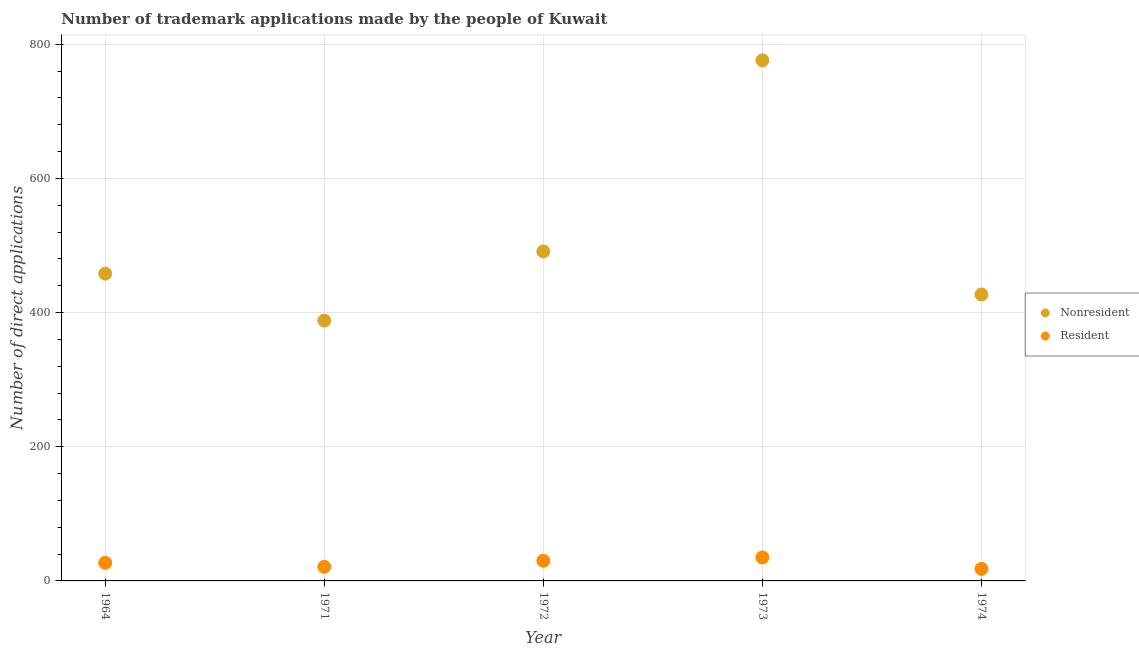How many different coloured dotlines are there?
Give a very brief answer. 2. What is the number of trademark applications made by non residents in 1971?
Give a very brief answer. 388. Across all years, what is the maximum number of trademark applications made by non residents?
Keep it short and to the point. 776. Across all years, what is the minimum number of trademark applications made by non residents?
Give a very brief answer. 388. What is the total number of trademark applications made by residents in the graph?
Provide a succinct answer. 131. What is the difference between the number of trademark applications made by residents in 1971 and that in 1973?
Provide a short and direct response. -14. What is the difference between the number of trademark applications made by non residents in 1964 and the number of trademark applications made by residents in 1971?
Your answer should be very brief. 437. What is the average number of trademark applications made by non residents per year?
Give a very brief answer. 508. In the year 1973, what is the difference between the number of trademark applications made by residents and number of trademark applications made by non residents?
Give a very brief answer. -741. In how many years, is the number of trademark applications made by non residents greater than 560?
Offer a very short reply. 1. Is the difference between the number of trademark applications made by non residents in 1971 and 1973 greater than the difference between the number of trademark applications made by residents in 1971 and 1973?
Your answer should be compact. No. What is the difference between the highest and the second highest number of trademark applications made by residents?
Your response must be concise. 5. What is the difference between the highest and the lowest number of trademark applications made by non residents?
Keep it short and to the point. 388. Does the number of trademark applications made by residents monotonically increase over the years?
Ensure brevity in your answer.  No. Are the values on the major ticks of Y-axis written in scientific E-notation?
Keep it short and to the point. No. Does the graph contain any zero values?
Offer a very short reply. No. Does the graph contain grids?
Offer a terse response. Yes. Where does the legend appear in the graph?
Make the answer very short. Center right. How are the legend labels stacked?
Your answer should be very brief. Vertical. What is the title of the graph?
Provide a short and direct response. Number of trademark applications made by the people of Kuwait. Does "Male" appear as one of the legend labels in the graph?
Your answer should be compact. No. What is the label or title of the Y-axis?
Provide a short and direct response. Number of direct applications. What is the Number of direct applications of Nonresident in 1964?
Provide a short and direct response. 458. What is the Number of direct applications of Resident in 1964?
Offer a terse response. 27. What is the Number of direct applications in Nonresident in 1971?
Ensure brevity in your answer.  388. What is the Number of direct applications of Nonresident in 1972?
Ensure brevity in your answer.  491. What is the Number of direct applications of Nonresident in 1973?
Offer a terse response. 776. What is the Number of direct applications of Nonresident in 1974?
Keep it short and to the point. 427. Across all years, what is the maximum Number of direct applications of Nonresident?
Keep it short and to the point. 776. Across all years, what is the minimum Number of direct applications in Nonresident?
Give a very brief answer. 388. Across all years, what is the minimum Number of direct applications in Resident?
Make the answer very short. 18. What is the total Number of direct applications in Nonresident in the graph?
Give a very brief answer. 2540. What is the total Number of direct applications of Resident in the graph?
Make the answer very short. 131. What is the difference between the Number of direct applications of Resident in 1964 and that in 1971?
Make the answer very short. 6. What is the difference between the Number of direct applications in Nonresident in 1964 and that in 1972?
Your response must be concise. -33. What is the difference between the Number of direct applications in Nonresident in 1964 and that in 1973?
Offer a very short reply. -318. What is the difference between the Number of direct applications in Nonresident in 1971 and that in 1972?
Provide a short and direct response. -103. What is the difference between the Number of direct applications in Resident in 1971 and that in 1972?
Offer a terse response. -9. What is the difference between the Number of direct applications in Nonresident in 1971 and that in 1973?
Your answer should be very brief. -388. What is the difference between the Number of direct applications in Nonresident in 1971 and that in 1974?
Make the answer very short. -39. What is the difference between the Number of direct applications in Nonresident in 1972 and that in 1973?
Offer a very short reply. -285. What is the difference between the Number of direct applications of Nonresident in 1972 and that in 1974?
Provide a succinct answer. 64. What is the difference between the Number of direct applications in Nonresident in 1973 and that in 1974?
Provide a succinct answer. 349. What is the difference between the Number of direct applications in Nonresident in 1964 and the Number of direct applications in Resident in 1971?
Offer a very short reply. 437. What is the difference between the Number of direct applications of Nonresident in 1964 and the Number of direct applications of Resident in 1972?
Your answer should be compact. 428. What is the difference between the Number of direct applications in Nonresident in 1964 and the Number of direct applications in Resident in 1973?
Your answer should be compact. 423. What is the difference between the Number of direct applications of Nonresident in 1964 and the Number of direct applications of Resident in 1974?
Your answer should be compact. 440. What is the difference between the Number of direct applications in Nonresident in 1971 and the Number of direct applications in Resident in 1972?
Your response must be concise. 358. What is the difference between the Number of direct applications of Nonresident in 1971 and the Number of direct applications of Resident in 1973?
Make the answer very short. 353. What is the difference between the Number of direct applications of Nonresident in 1971 and the Number of direct applications of Resident in 1974?
Ensure brevity in your answer.  370. What is the difference between the Number of direct applications of Nonresident in 1972 and the Number of direct applications of Resident in 1973?
Provide a succinct answer. 456. What is the difference between the Number of direct applications in Nonresident in 1972 and the Number of direct applications in Resident in 1974?
Your answer should be compact. 473. What is the difference between the Number of direct applications of Nonresident in 1973 and the Number of direct applications of Resident in 1974?
Your answer should be very brief. 758. What is the average Number of direct applications in Nonresident per year?
Your answer should be compact. 508. What is the average Number of direct applications in Resident per year?
Give a very brief answer. 26.2. In the year 1964, what is the difference between the Number of direct applications of Nonresident and Number of direct applications of Resident?
Make the answer very short. 431. In the year 1971, what is the difference between the Number of direct applications of Nonresident and Number of direct applications of Resident?
Give a very brief answer. 367. In the year 1972, what is the difference between the Number of direct applications of Nonresident and Number of direct applications of Resident?
Provide a short and direct response. 461. In the year 1973, what is the difference between the Number of direct applications in Nonresident and Number of direct applications in Resident?
Your response must be concise. 741. In the year 1974, what is the difference between the Number of direct applications in Nonresident and Number of direct applications in Resident?
Keep it short and to the point. 409. What is the ratio of the Number of direct applications in Nonresident in 1964 to that in 1971?
Offer a very short reply. 1.18. What is the ratio of the Number of direct applications of Nonresident in 1964 to that in 1972?
Make the answer very short. 0.93. What is the ratio of the Number of direct applications of Nonresident in 1964 to that in 1973?
Offer a very short reply. 0.59. What is the ratio of the Number of direct applications of Resident in 1964 to that in 1973?
Your answer should be very brief. 0.77. What is the ratio of the Number of direct applications of Nonresident in 1964 to that in 1974?
Your response must be concise. 1.07. What is the ratio of the Number of direct applications in Nonresident in 1971 to that in 1972?
Provide a succinct answer. 0.79. What is the ratio of the Number of direct applications in Resident in 1971 to that in 1972?
Provide a succinct answer. 0.7. What is the ratio of the Number of direct applications of Resident in 1971 to that in 1973?
Ensure brevity in your answer.  0.6. What is the ratio of the Number of direct applications in Nonresident in 1971 to that in 1974?
Make the answer very short. 0.91. What is the ratio of the Number of direct applications of Resident in 1971 to that in 1974?
Give a very brief answer. 1.17. What is the ratio of the Number of direct applications of Nonresident in 1972 to that in 1973?
Provide a short and direct response. 0.63. What is the ratio of the Number of direct applications of Resident in 1972 to that in 1973?
Keep it short and to the point. 0.86. What is the ratio of the Number of direct applications in Nonresident in 1972 to that in 1974?
Make the answer very short. 1.15. What is the ratio of the Number of direct applications in Resident in 1972 to that in 1974?
Provide a succinct answer. 1.67. What is the ratio of the Number of direct applications in Nonresident in 1973 to that in 1974?
Give a very brief answer. 1.82. What is the ratio of the Number of direct applications of Resident in 1973 to that in 1974?
Offer a very short reply. 1.94. What is the difference between the highest and the second highest Number of direct applications in Nonresident?
Ensure brevity in your answer.  285. What is the difference between the highest and the second highest Number of direct applications of Resident?
Ensure brevity in your answer.  5. What is the difference between the highest and the lowest Number of direct applications of Nonresident?
Your answer should be very brief. 388. 